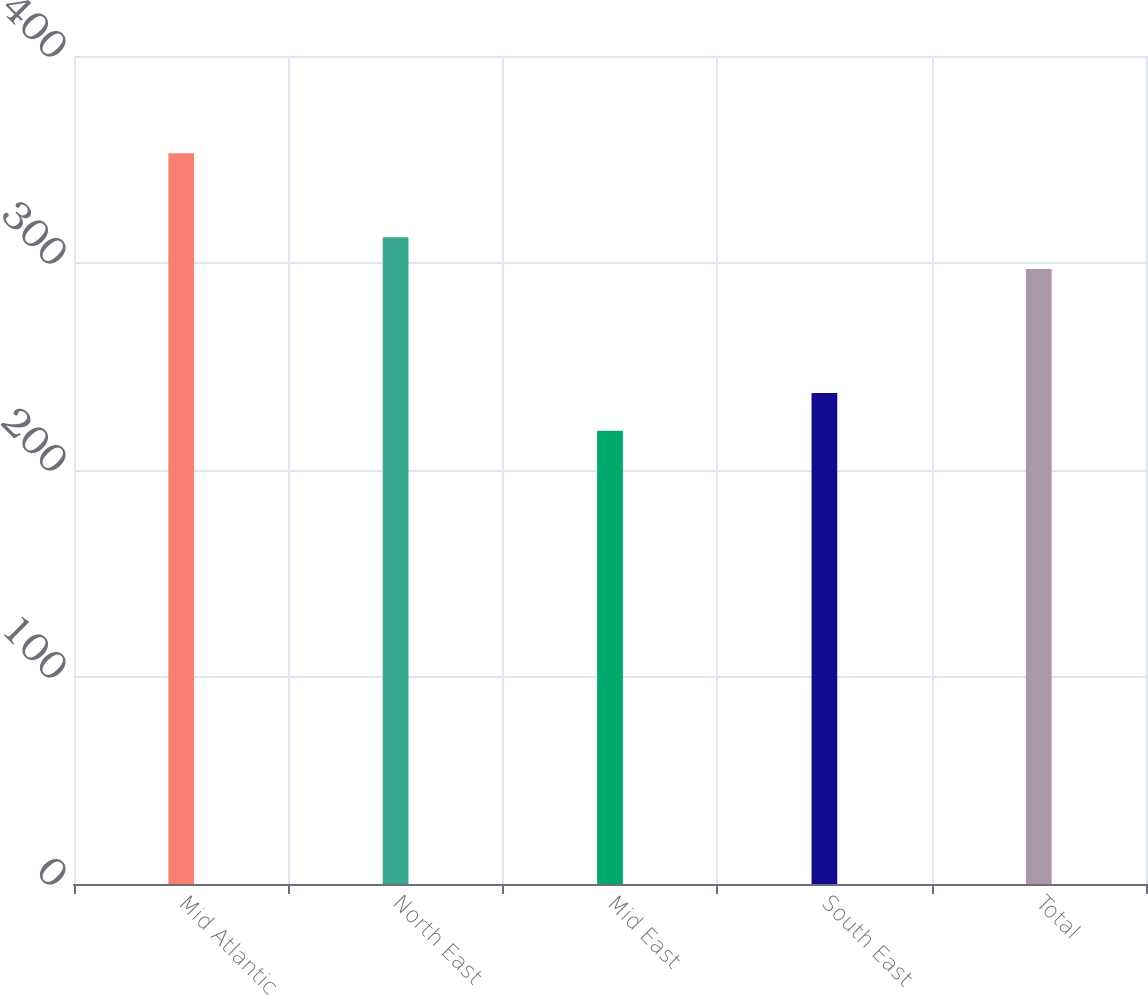<chart> <loc_0><loc_0><loc_500><loc_500><bar_chart><fcel>Mid Atlantic<fcel>North East<fcel>Mid East<fcel>South East<fcel>Total<nl><fcel>353<fcel>312.5<fcel>219<fcel>237.2<fcel>297.1<nl></chart> 